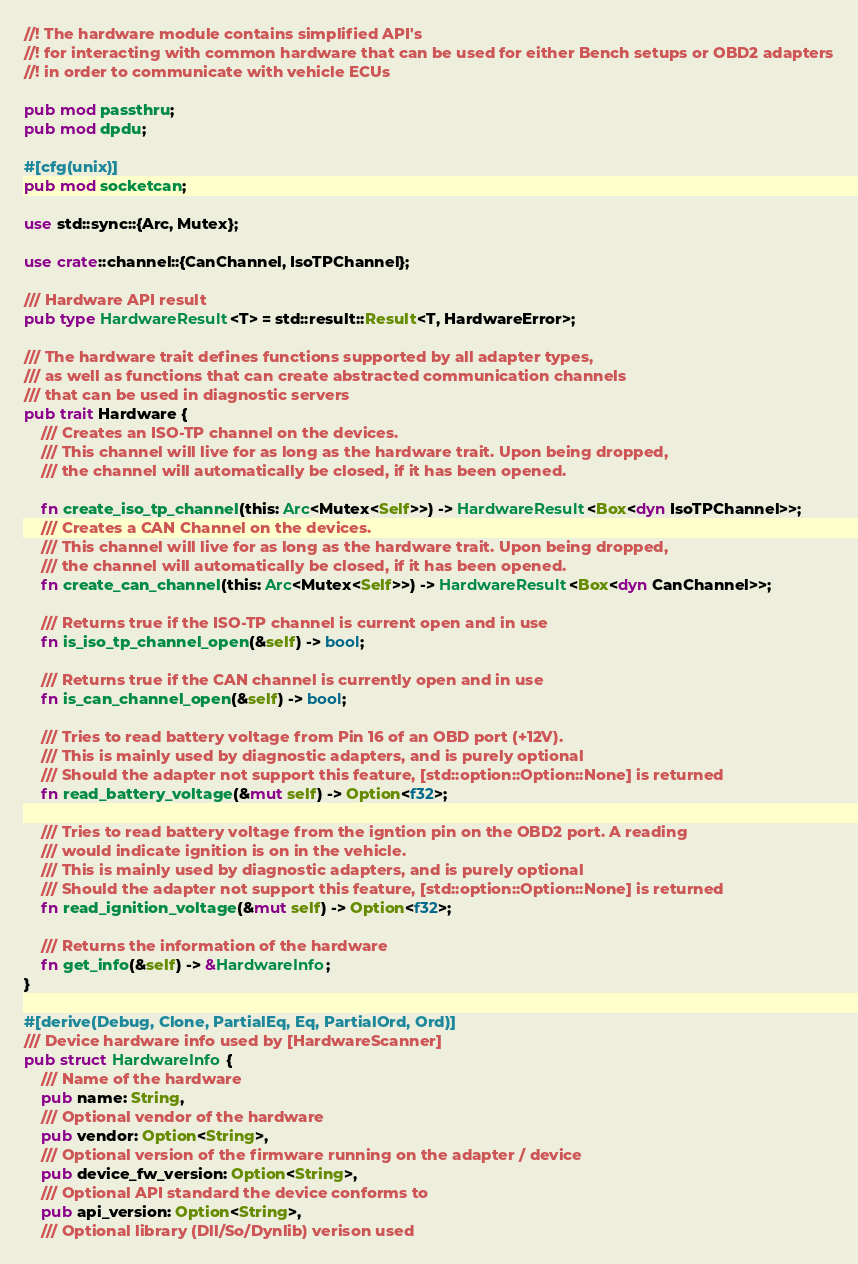<code> <loc_0><loc_0><loc_500><loc_500><_Rust_>//! The hardware module contains simplified API's
//! for interacting with common hardware that can be used for either Bench setups or OBD2 adapters
//! in order to communicate with vehicle ECUs

pub mod passthru;
pub mod dpdu;

#[cfg(unix)]
pub mod socketcan;

use std::sync::{Arc, Mutex};

use crate::channel::{CanChannel, IsoTPChannel};

/// Hardware API result
pub type HardwareResult<T> = std::result::Result<T, HardwareError>;

/// The hardware trait defines functions supported by all adapter types,
/// as well as functions that can create abstracted communication channels
/// that can be used in diagnostic servers
pub trait Hardware {
    /// Creates an ISO-TP channel on the devices.
    /// This channel will live for as long as the hardware trait. Upon being dropped,
    /// the channel will automatically be closed, if it has been opened.

    fn create_iso_tp_channel(this: Arc<Mutex<Self>>) -> HardwareResult<Box<dyn IsoTPChannel>>;
    /// Creates a CAN Channel on the devices.
    /// This channel will live for as long as the hardware trait. Upon being dropped,
    /// the channel will automatically be closed, if it has been opened.
    fn create_can_channel(this: Arc<Mutex<Self>>) -> HardwareResult<Box<dyn CanChannel>>;

    /// Returns true if the ISO-TP channel is current open and in use
    fn is_iso_tp_channel_open(&self) -> bool;
    
    /// Returns true if the CAN channel is currently open and in use
    fn is_can_channel_open(&self) -> bool;

    /// Tries to read battery voltage from Pin 16 of an OBD port (+12V).
    /// This is mainly used by diagnostic adapters, and is purely optional
    /// Should the adapter not support this feature, [std::option::Option::None] is returned
    fn read_battery_voltage(&mut self) -> Option<f32>;

    /// Tries to read battery voltage from the igntion pin on the OBD2 port. A reading
    /// would indicate ignition is on in the vehicle.
    /// This is mainly used by diagnostic adapters, and is purely optional
    /// Should the adapter not support this feature, [std::option::Option::None] is returned
    fn read_ignition_voltage(&mut self) -> Option<f32>;

    /// Returns the information of the hardware
    fn get_info(&self) -> &HardwareInfo;
}

#[derive(Debug, Clone, PartialEq, Eq, PartialOrd, Ord)]
/// Device hardware info used by [HardwareScanner]
pub struct HardwareInfo {
    /// Name of the hardware
    pub name: String,
    /// Optional vendor of the hardware
    pub vendor: Option<String>,
    /// Optional version of the firmware running on the adapter / device
    pub device_fw_version: Option<String>,
    /// Optional API standard the device conforms to
    pub api_version: Option<String>,
    /// Optional library (Dll/So/Dynlib) verison used</code> 